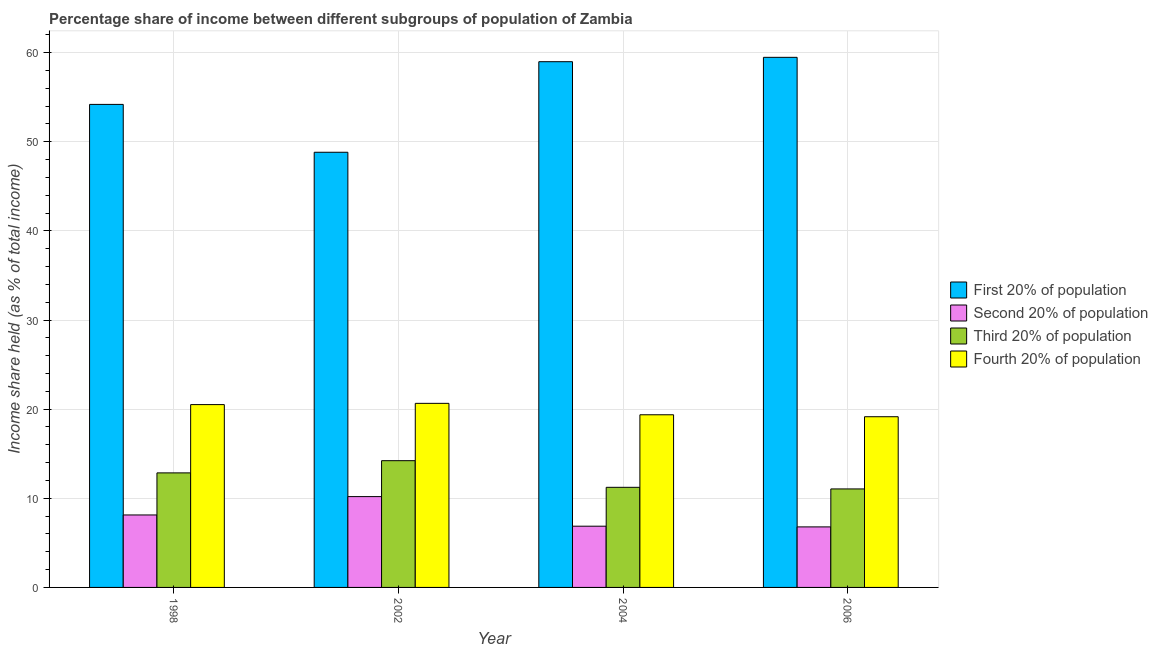How many groups of bars are there?
Give a very brief answer. 4. Are the number of bars per tick equal to the number of legend labels?
Your answer should be very brief. Yes. Are the number of bars on each tick of the X-axis equal?
Ensure brevity in your answer.  Yes. What is the label of the 1st group of bars from the left?
Your answer should be very brief. 1998. What is the share of the income held by first 20% of the population in 2006?
Provide a succinct answer. 59.47. Across all years, what is the maximum share of the income held by first 20% of the population?
Keep it short and to the point. 59.47. Across all years, what is the minimum share of the income held by third 20% of the population?
Offer a very short reply. 11.05. In which year was the share of the income held by first 20% of the population maximum?
Offer a terse response. 2006. In which year was the share of the income held by fourth 20% of the population minimum?
Provide a succinct answer. 2006. What is the total share of the income held by first 20% of the population in the graph?
Offer a terse response. 221.46. What is the difference between the share of the income held by fourth 20% of the population in 2004 and that in 2006?
Provide a short and direct response. 0.22. What is the difference between the share of the income held by third 20% of the population in 2004 and the share of the income held by first 20% of the population in 1998?
Your response must be concise. -1.62. What is the average share of the income held by second 20% of the population per year?
Your answer should be very brief. 8. In the year 1998, what is the difference between the share of the income held by third 20% of the population and share of the income held by second 20% of the population?
Give a very brief answer. 0. In how many years, is the share of the income held by second 20% of the population greater than 6 %?
Offer a very short reply. 4. What is the ratio of the share of the income held by first 20% of the population in 2004 to that in 2006?
Keep it short and to the point. 0.99. What is the difference between the highest and the second highest share of the income held by third 20% of the population?
Give a very brief answer. 1.37. What does the 1st bar from the left in 2006 represents?
Give a very brief answer. First 20% of population. What does the 1st bar from the right in 2002 represents?
Offer a terse response. Fourth 20% of population. How many bars are there?
Offer a terse response. 16. Does the graph contain any zero values?
Provide a succinct answer. No. Where does the legend appear in the graph?
Keep it short and to the point. Center right. How many legend labels are there?
Keep it short and to the point. 4. How are the legend labels stacked?
Offer a very short reply. Vertical. What is the title of the graph?
Offer a terse response. Percentage share of income between different subgroups of population of Zambia. Does "Efficiency of custom clearance process" appear as one of the legend labels in the graph?
Provide a short and direct response. No. What is the label or title of the Y-axis?
Give a very brief answer. Income share held (as % of total income). What is the Income share held (as % of total income) in First 20% of population in 1998?
Your answer should be compact. 54.19. What is the Income share held (as % of total income) of Second 20% of population in 1998?
Provide a short and direct response. 8.13. What is the Income share held (as % of total income) in Third 20% of population in 1998?
Offer a terse response. 12.85. What is the Income share held (as % of total income) in Fourth 20% of population in 1998?
Your answer should be very brief. 20.51. What is the Income share held (as % of total income) of First 20% of population in 2002?
Offer a terse response. 48.82. What is the Income share held (as % of total income) in Second 20% of population in 2002?
Your answer should be very brief. 10.19. What is the Income share held (as % of total income) of Third 20% of population in 2002?
Your answer should be very brief. 14.22. What is the Income share held (as % of total income) of Fourth 20% of population in 2002?
Provide a short and direct response. 20.65. What is the Income share held (as % of total income) in First 20% of population in 2004?
Offer a very short reply. 58.98. What is the Income share held (as % of total income) in Second 20% of population in 2004?
Offer a terse response. 6.87. What is the Income share held (as % of total income) in Third 20% of population in 2004?
Your answer should be very brief. 11.23. What is the Income share held (as % of total income) of Fourth 20% of population in 2004?
Offer a very short reply. 19.37. What is the Income share held (as % of total income) of First 20% of population in 2006?
Provide a succinct answer. 59.47. What is the Income share held (as % of total income) in Second 20% of population in 2006?
Provide a succinct answer. 6.79. What is the Income share held (as % of total income) in Third 20% of population in 2006?
Give a very brief answer. 11.05. What is the Income share held (as % of total income) in Fourth 20% of population in 2006?
Your response must be concise. 19.15. Across all years, what is the maximum Income share held (as % of total income) of First 20% of population?
Provide a short and direct response. 59.47. Across all years, what is the maximum Income share held (as % of total income) in Second 20% of population?
Your response must be concise. 10.19. Across all years, what is the maximum Income share held (as % of total income) of Third 20% of population?
Offer a very short reply. 14.22. Across all years, what is the maximum Income share held (as % of total income) in Fourth 20% of population?
Offer a very short reply. 20.65. Across all years, what is the minimum Income share held (as % of total income) of First 20% of population?
Your response must be concise. 48.82. Across all years, what is the minimum Income share held (as % of total income) of Second 20% of population?
Your answer should be compact. 6.79. Across all years, what is the minimum Income share held (as % of total income) of Third 20% of population?
Offer a very short reply. 11.05. Across all years, what is the minimum Income share held (as % of total income) in Fourth 20% of population?
Your answer should be compact. 19.15. What is the total Income share held (as % of total income) in First 20% of population in the graph?
Offer a very short reply. 221.46. What is the total Income share held (as % of total income) in Second 20% of population in the graph?
Provide a succinct answer. 31.98. What is the total Income share held (as % of total income) in Third 20% of population in the graph?
Ensure brevity in your answer.  49.35. What is the total Income share held (as % of total income) in Fourth 20% of population in the graph?
Offer a terse response. 79.68. What is the difference between the Income share held (as % of total income) in First 20% of population in 1998 and that in 2002?
Ensure brevity in your answer.  5.37. What is the difference between the Income share held (as % of total income) in Second 20% of population in 1998 and that in 2002?
Keep it short and to the point. -2.06. What is the difference between the Income share held (as % of total income) of Third 20% of population in 1998 and that in 2002?
Your answer should be very brief. -1.37. What is the difference between the Income share held (as % of total income) in Fourth 20% of population in 1998 and that in 2002?
Your answer should be very brief. -0.14. What is the difference between the Income share held (as % of total income) of First 20% of population in 1998 and that in 2004?
Ensure brevity in your answer.  -4.79. What is the difference between the Income share held (as % of total income) of Second 20% of population in 1998 and that in 2004?
Provide a short and direct response. 1.26. What is the difference between the Income share held (as % of total income) of Third 20% of population in 1998 and that in 2004?
Make the answer very short. 1.62. What is the difference between the Income share held (as % of total income) in Fourth 20% of population in 1998 and that in 2004?
Your answer should be compact. 1.14. What is the difference between the Income share held (as % of total income) in First 20% of population in 1998 and that in 2006?
Your answer should be compact. -5.28. What is the difference between the Income share held (as % of total income) of Second 20% of population in 1998 and that in 2006?
Your response must be concise. 1.34. What is the difference between the Income share held (as % of total income) in Fourth 20% of population in 1998 and that in 2006?
Offer a very short reply. 1.36. What is the difference between the Income share held (as % of total income) in First 20% of population in 2002 and that in 2004?
Provide a short and direct response. -10.16. What is the difference between the Income share held (as % of total income) of Second 20% of population in 2002 and that in 2004?
Your answer should be very brief. 3.32. What is the difference between the Income share held (as % of total income) of Third 20% of population in 2002 and that in 2004?
Offer a terse response. 2.99. What is the difference between the Income share held (as % of total income) in Fourth 20% of population in 2002 and that in 2004?
Offer a very short reply. 1.28. What is the difference between the Income share held (as % of total income) of First 20% of population in 2002 and that in 2006?
Provide a succinct answer. -10.65. What is the difference between the Income share held (as % of total income) in Second 20% of population in 2002 and that in 2006?
Your answer should be very brief. 3.4. What is the difference between the Income share held (as % of total income) in Third 20% of population in 2002 and that in 2006?
Your response must be concise. 3.17. What is the difference between the Income share held (as % of total income) in First 20% of population in 2004 and that in 2006?
Provide a succinct answer. -0.49. What is the difference between the Income share held (as % of total income) of Second 20% of population in 2004 and that in 2006?
Keep it short and to the point. 0.08. What is the difference between the Income share held (as % of total income) in Third 20% of population in 2004 and that in 2006?
Ensure brevity in your answer.  0.18. What is the difference between the Income share held (as % of total income) of Fourth 20% of population in 2004 and that in 2006?
Keep it short and to the point. 0.22. What is the difference between the Income share held (as % of total income) in First 20% of population in 1998 and the Income share held (as % of total income) in Second 20% of population in 2002?
Make the answer very short. 44. What is the difference between the Income share held (as % of total income) in First 20% of population in 1998 and the Income share held (as % of total income) in Third 20% of population in 2002?
Keep it short and to the point. 39.97. What is the difference between the Income share held (as % of total income) in First 20% of population in 1998 and the Income share held (as % of total income) in Fourth 20% of population in 2002?
Provide a short and direct response. 33.54. What is the difference between the Income share held (as % of total income) of Second 20% of population in 1998 and the Income share held (as % of total income) of Third 20% of population in 2002?
Make the answer very short. -6.09. What is the difference between the Income share held (as % of total income) of Second 20% of population in 1998 and the Income share held (as % of total income) of Fourth 20% of population in 2002?
Provide a succinct answer. -12.52. What is the difference between the Income share held (as % of total income) in First 20% of population in 1998 and the Income share held (as % of total income) in Second 20% of population in 2004?
Offer a terse response. 47.32. What is the difference between the Income share held (as % of total income) of First 20% of population in 1998 and the Income share held (as % of total income) of Third 20% of population in 2004?
Provide a succinct answer. 42.96. What is the difference between the Income share held (as % of total income) in First 20% of population in 1998 and the Income share held (as % of total income) in Fourth 20% of population in 2004?
Your answer should be compact. 34.82. What is the difference between the Income share held (as % of total income) in Second 20% of population in 1998 and the Income share held (as % of total income) in Fourth 20% of population in 2004?
Provide a succinct answer. -11.24. What is the difference between the Income share held (as % of total income) of Third 20% of population in 1998 and the Income share held (as % of total income) of Fourth 20% of population in 2004?
Provide a succinct answer. -6.52. What is the difference between the Income share held (as % of total income) of First 20% of population in 1998 and the Income share held (as % of total income) of Second 20% of population in 2006?
Make the answer very short. 47.4. What is the difference between the Income share held (as % of total income) of First 20% of population in 1998 and the Income share held (as % of total income) of Third 20% of population in 2006?
Your answer should be very brief. 43.14. What is the difference between the Income share held (as % of total income) of First 20% of population in 1998 and the Income share held (as % of total income) of Fourth 20% of population in 2006?
Offer a very short reply. 35.04. What is the difference between the Income share held (as % of total income) in Second 20% of population in 1998 and the Income share held (as % of total income) in Third 20% of population in 2006?
Your answer should be very brief. -2.92. What is the difference between the Income share held (as % of total income) of Second 20% of population in 1998 and the Income share held (as % of total income) of Fourth 20% of population in 2006?
Ensure brevity in your answer.  -11.02. What is the difference between the Income share held (as % of total income) in First 20% of population in 2002 and the Income share held (as % of total income) in Second 20% of population in 2004?
Your answer should be very brief. 41.95. What is the difference between the Income share held (as % of total income) of First 20% of population in 2002 and the Income share held (as % of total income) of Third 20% of population in 2004?
Make the answer very short. 37.59. What is the difference between the Income share held (as % of total income) of First 20% of population in 2002 and the Income share held (as % of total income) of Fourth 20% of population in 2004?
Offer a terse response. 29.45. What is the difference between the Income share held (as % of total income) of Second 20% of population in 2002 and the Income share held (as % of total income) of Third 20% of population in 2004?
Your response must be concise. -1.04. What is the difference between the Income share held (as % of total income) of Second 20% of population in 2002 and the Income share held (as % of total income) of Fourth 20% of population in 2004?
Ensure brevity in your answer.  -9.18. What is the difference between the Income share held (as % of total income) in Third 20% of population in 2002 and the Income share held (as % of total income) in Fourth 20% of population in 2004?
Your response must be concise. -5.15. What is the difference between the Income share held (as % of total income) in First 20% of population in 2002 and the Income share held (as % of total income) in Second 20% of population in 2006?
Offer a terse response. 42.03. What is the difference between the Income share held (as % of total income) of First 20% of population in 2002 and the Income share held (as % of total income) of Third 20% of population in 2006?
Keep it short and to the point. 37.77. What is the difference between the Income share held (as % of total income) of First 20% of population in 2002 and the Income share held (as % of total income) of Fourth 20% of population in 2006?
Your response must be concise. 29.67. What is the difference between the Income share held (as % of total income) of Second 20% of population in 2002 and the Income share held (as % of total income) of Third 20% of population in 2006?
Your answer should be very brief. -0.86. What is the difference between the Income share held (as % of total income) in Second 20% of population in 2002 and the Income share held (as % of total income) in Fourth 20% of population in 2006?
Provide a short and direct response. -8.96. What is the difference between the Income share held (as % of total income) in Third 20% of population in 2002 and the Income share held (as % of total income) in Fourth 20% of population in 2006?
Ensure brevity in your answer.  -4.93. What is the difference between the Income share held (as % of total income) of First 20% of population in 2004 and the Income share held (as % of total income) of Second 20% of population in 2006?
Your answer should be very brief. 52.19. What is the difference between the Income share held (as % of total income) in First 20% of population in 2004 and the Income share held (as % of total income) in Third 20% of population in 2006?
Your answer should be compact. 47.93. What is the difference between the Income share held (as % of total income) in First 20% of population in 2004 and the Income share held (as % of total income) in Fourth 20% of population in 2006?
Make the answer very short. 39.83. What is the difference between the Income share held (as % of total income) of Second 20% of population in 2004 and the Income share held (as % of total income) of Third 20% of population in 2006?
Make the answer very short. -4.18. What is the difference between the Income share held (as % of total income) of Second 20% of population in 2004 and the Income share held (as % of total income) of Fourth 20% of population in 2006?
Ensure brevity in your answer.  -12.28. What is the difference between the Income share held (as % of total income) in Third 20% of population in 2004 and the Income share held (as % of total income) in Fourth 20% of population in 2006?
Ensure brevity in your answer.  -7.92. What is the average Income share held (as % of total income) of First 20% of population per year?
Your response must be concise. 55.37. What is the average Income share held (as % of total income) of Second 20% of population per year?
Offer a very short reply. 8. What is the average Income share held (as % of total income) in Third 20% of population per year?
Keep it short and to the point. 12.34. What is the average Income share held (as % of total income) in Fourth 20% of population per year?
Offer a very short reply. 19.92. In the year 1998, what is the difference between the Income share held (as % of total income) of First 20% of population and Income share held (as % of total income) of Second 20% of population?
Your response must be concise. 46.06. In the year 1998, what is the difference between the Income share held (as % of total income) of First 20% of population and Income share held (as % of total income) of Third 20% of population?
Give a very brief answer. 41.34. In the year 1998, what is the difference between the Income share held (as % of total income) of First 20% of population and Income share held (as % of total income) of Fourth 20% of population?
Keep it short and to the point. 33.68. In the year 1998, what is the difference between the Income share held (as % of total income) in Second 20% of population and Income share held (as % of total income) in Third 20% of population?
Provide a short and direct response. -4.72. In the year 1998, what is the difference between the Income share held (as % of total income) in Second 20% of population and Income share held (as % of total income) in Fourth 20% of population?
Your answer should be compact. -12.38. In the year 1998, what is the difference between the Income share held (as % of total income) in Third 20% of population and Income share held (as % of total income) in Fourth 20% of population?
Keep it short and to the point. -7.66. In the year 2002, what is the difference between the Income share held (as % of total income) of First 20% of population and Income share held (as % of total income) of Second 20% of population?
Provide a succinct answer. 38.63. In the year 2002, what is the difference between the Income share held (as % of total income) in First 20% of population and Income share held (as % of total income) in Third 20% of population?
Your response must be concise. 34.6. In the year 2002, what is the difference between the Income share held (as % of total income) in First 20% of population and Income share held (as % of total income) in Fourth 20% of population?
Provide a succinct answer. 28.17. In the year 2002, what is the difference between the Income share held (as % of total income) of Second 20% of population and Income share held (as % of total income) of Third 20% of population?
Provide a succinct answer. -4.03. In the year 2002, what is the difference between the Income share held (as % of total income) in Second 20% of population and Income share held (as % of total income) in Fourth 20% of population?
Keep it short and to the point. -10.46. In the year 2002, what is the difference between the Income share held (as % of total income) of Third 20% of population and Income share held (as % of total income) of Fourth 20% of population?
Give a very brief answer. -6.43. In the year 2004, what is the difference between the Income share held (as % of total income) of First 20% of population and Income share held (as % of total income) of Second 20% of population?
Provide a succinct answer. 52.11. In the year 2004, what is the difference between the Income share held (as % of total income) in First 20% of population and Income share held (as % of total income) in Third 20% of population?
Offer a terse response. 47.75. In the year 2004, what is the difference between the Income share held (as % of total income) in First 20% of population and Income share held (as % of total income) in Fourth 20% of population?
Provide a succinct answer. 39.61. In the year 2004, what is the difference between the Income share held (as % of total income) of Second 20% of population and Income share held (as % of total income) of Third 20% of population?
Offer a terse response. -4.36. In the year 2004, what is the difference between the Income share held (as % of total income) of Second 20% of population and Income share held (as % of total income) of Fourth 20% of population?
Your answer should be very brief. -12.5. In the year 2004, what is the difference between the Income share held (as % of total income) in Third 20% of population and Income share held (as % of total income) in Fourth 20% of population?
Offer a very short reply. -8.14. In the year 2006, what is the difference between the Income share held (as % of total income) in First 20% of population and Income share held (as % of total income) in Second 20% of population?
Your answer should be compact. 52.68. In the year 2006, what is the difference between the Income share held (as % of total income) in First 20% of population and Income share held (as % of total income) in Third 20% of population?
Keep it short and to the point. 48.42. In the year 2006, what is the difference between the Income share held (as % of total income) of First 20% of population and Income share held (as % of total income) of Fourth 20% of population?
Ensure brevity in your answer.  40.32. In the year 2006, what is the difference between the Income share held (as % of total income) in Second 20% of population and Income share held (as % of total income) in Third 20% of population?
Your response must be concise. -4.26. In the year 2006, what is the difference between the Income share held (as % of total income) of Second 20% of population and Income share held (as % of total income) of Fourth 20% of population?
Keep it short and to the point. -12.36. In the year 2006, what is the difference between the Income share held (as % of total income) of Third 20% of population and Income share held (as % of total income) of Fourth 20% of population?
Provide a short and direct response. -8.1. What is the ratio of the Income share held (as % of total income) in First 20% of population in 1998 to that in 2002?
Offer a terse response. 1.11. What is the ratio of the Income share held (as % of total income) of Second 20% of population in 1998 to that in 2002?
Ensure brevity in your answer.  0.8. What is the ratio of the Income share held (as % of total income) in Third 20% of population in 1998 to that in 2002?
Give a very brief answer. 0.9. What is the ratio of the Income share held (as % of total income) of Fourth 20% of population in 1998 to that in 2002?
Your answer should be very brief. 0.99. What is the ratio of the Income share held (as % of total income) of First 20% of population in 1998 to that in 2004?
Keep it short and to the point. 0.92. What is the ratio of the Income share held (as % of total income) of Second 20% of population in 1998 to that in 2004?
Offer a terse response. 1.18. What is the ratio of the Income share held (as % of total income) in Third 20% of population in 1998 to that in 2004?
Provide a short and direct response. 1.14. What is the ratio of the Income share held (as % of total income) in Fourth 20% of population in 1998 to that in 2004?
Provide a succinct answer. 1.06. What is the ratio of the Income share held (as % of total income) of First 20% of population in 1998 to that in 2006?
Your answer should be compact. 0.91. What is the ratio of the Income share held (as % of total income) of Second 20% of population in 1998 to that in 2006?
Provide a succinct answer. 1.2. What is the ratio of the Income share held (as % of total income) of Third 20% of population in 1998 to that in 2006?
Make the answer very short. 1.16. What is the ratio of the Income share held (as % of total income) of Fourth 20% of population in 1998 to that in 2006?
Offer a terse response. 1.07. What is the ratio of the Income share held (as % of total income) of First 20% of population in 2002 to that in 2004?
Your answer should be very brief. 0.83. What is the ratio of the Income share held (as % of total income) of Second 20% of population in 2002 to that in 2004?
Offer a very short reply. 1.48. What is the ratio of the Income share held (as % of total income) of Third 20% of population in 2002 to that in 2004?
Keep it short and to the point. 1.27. What is the ratio of the Income share held (as % of total income) of Fourth 20% of population in 2002 to that in 2004?
Your answer should be compact. 1.07. What is the ratio of the Income share held (as % of total income) of First 20% of population in 2002 to that in 2006?
Your response must be concise. 0.82. What is the ratio of the Income share held (as % of total income) in Second 20% of population in 2002 to that in 2006?
Offer a very short reply. 1.5. What is the ratio of the Income share held (as % of total income) in Third 20% of population in 2002 to that in 2006?
Provide a succinct answer. 1.29. What is the ratio of the Income share held (as % of total income) in Fourth 20% of population in 2002 to that in 2006?
Ensure brevity in your answer.  1.08. What is the ratio of the Income share held (as % of total income) of First 20% of population in 2004 to that in 2006?
Make the answer very short. 0.99. What is the ratio of the Income share held (as % of total income) of Second 20% of population in 2004 to that in 2006?
Ensure brevity in your answer.  1.01. What is the ratio of the Income share held (as % of total income) in Third 20% of population in 2004 to that in 2006?
Your answer should be compact. 1.02. What is the ratio of the Income share held (as % of total income) in Fourth 20% of population in 2004 to that in 2006?
Your answer should be compact. 1.01. What is the difference between the highest and the second highest Income share held (as % of total income) in First 20% of population?
Provide a short and direct response. 0.49. What is the difference between the highest and the second highest Income share held (as % of total income) in Second 20% of population?
Provide a succinct answer. 2.06. What is the difference between the highest and the second highest Income share held (as % of total income) of Third 20% of population?
Ensure brevity in your answer.  1.37. What is the difference between the highest and the second highest Income share held (as % of total income) in Fourth 20% of population?
Your answer should be compact. 0.14. What is the difference between the highest and the lowest Income share held (as % of total income) of First 20% of population?
Your answer should be very brief. 10.65. What is the difference between the highest and the lowest Income share held (as % of total income) of Third 20% of population?
Your answer should be very brief. 3.17. 